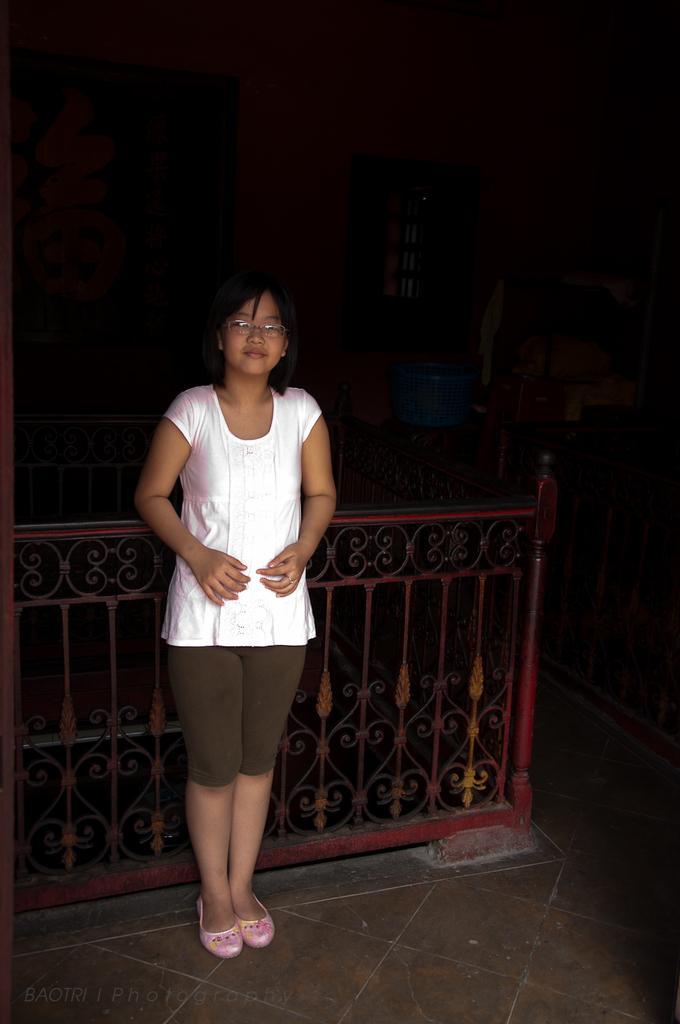Could you give a brief overview of what you see in this image? In this image we can see a person standing on the floor, clothes arranged in the cupboards, iron grills, window, door and walls. 